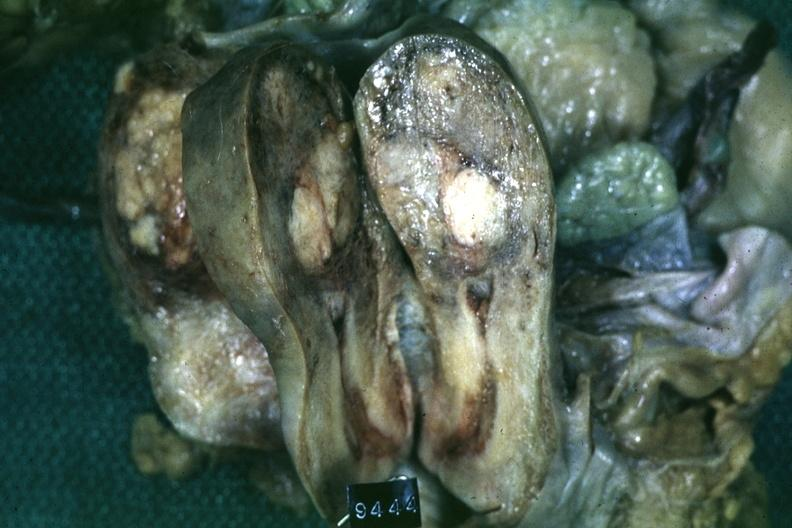s female reproductive present?
Answer the question using a single word or phrase. Yes 